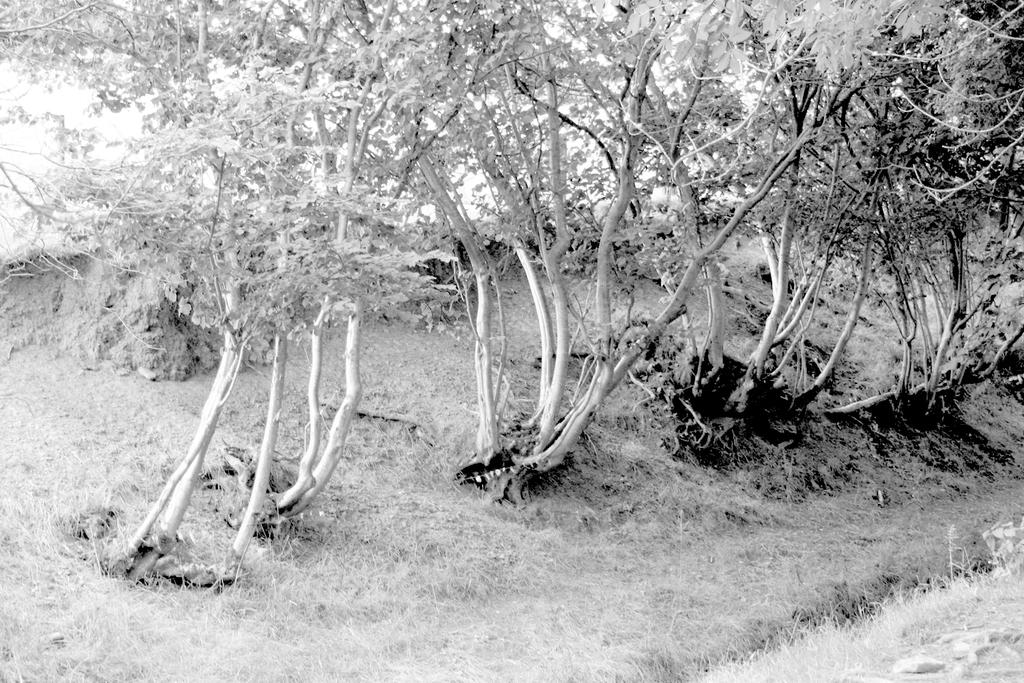What type of vegetation can be seen in the image? There is grass, plants, and trees in the image. Can you describe the natural environment depicted in the image? The image features a variety of vegetation, including grass, plants, and trees. How does the grass show respect to the trees in the image? The grass does not show respect to the trees in the image, as plants and trees do not have the ability to show respect. 